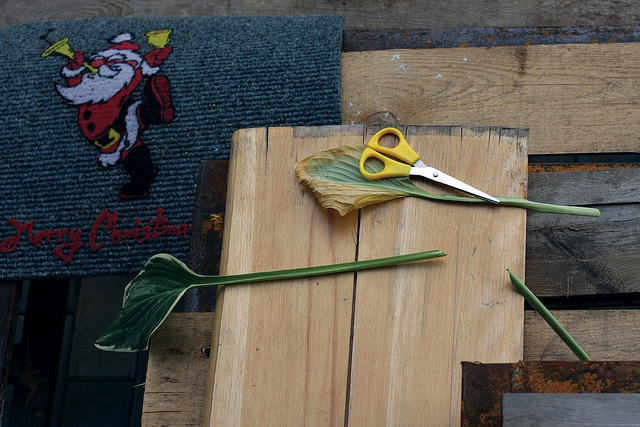Describe the objects in this image and their specific colors. I can see scissors in black, whitesmoke, khaki, and olive tones in this image. 